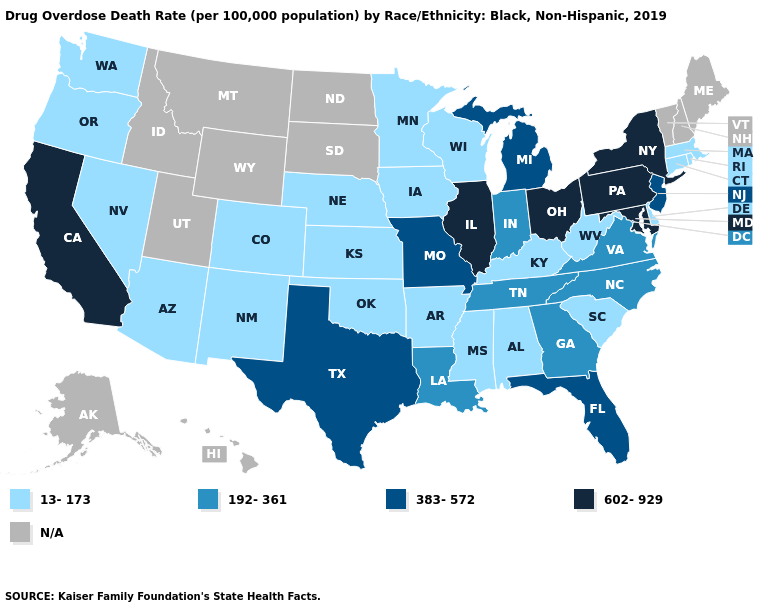What is the value of Illinois?
Short answer required. 602-929. Does Ohio have the lowest value in the USA?
Answer briefly. No. What is the value of South Dakota?
Write a very short answer. N/A. What is the value of North Dakota?
Quick response, please. N/A. Does the first symbol in the legend represent the smallest category?
Keep it brief. Yes. Name the states that have a value in the range 383-572?
Keep it brief. Florida, Michigan, Missouri, New Jersey, Texas. Among the states that border Kentucky , does West Virginia have the lowest value?
Short answer required. Yes. What is the value of Texas?
Concise answer only. 383-572. Which states have the highest value in the USA?
Concise answer only. California, Illinois, Maryland, New York, Ohio, Pennsylvania. How many symbols are there in the legend?
Give a very brief answer. 5. What is the value of Washington?
Be succinct. 13-173. Name the states that have a value in the range 13-173?
Short answer required. Alabama, Arizona, Arkansas, Colorado, Connecticut, Delaware, Iowa, Kansas, Kentucky, Massachusetts, Minnesota, Mississippi, Nebraska, Nevada, New Mexico, Oklahoma, Oregon, Rhode Island, South Carolina, Washington, West Virginia, Wisconsin. Name the states that have a value in the range 383-572?
Quick response, please. Florida, Michigan, Missouri, New Jersey, Texas. 